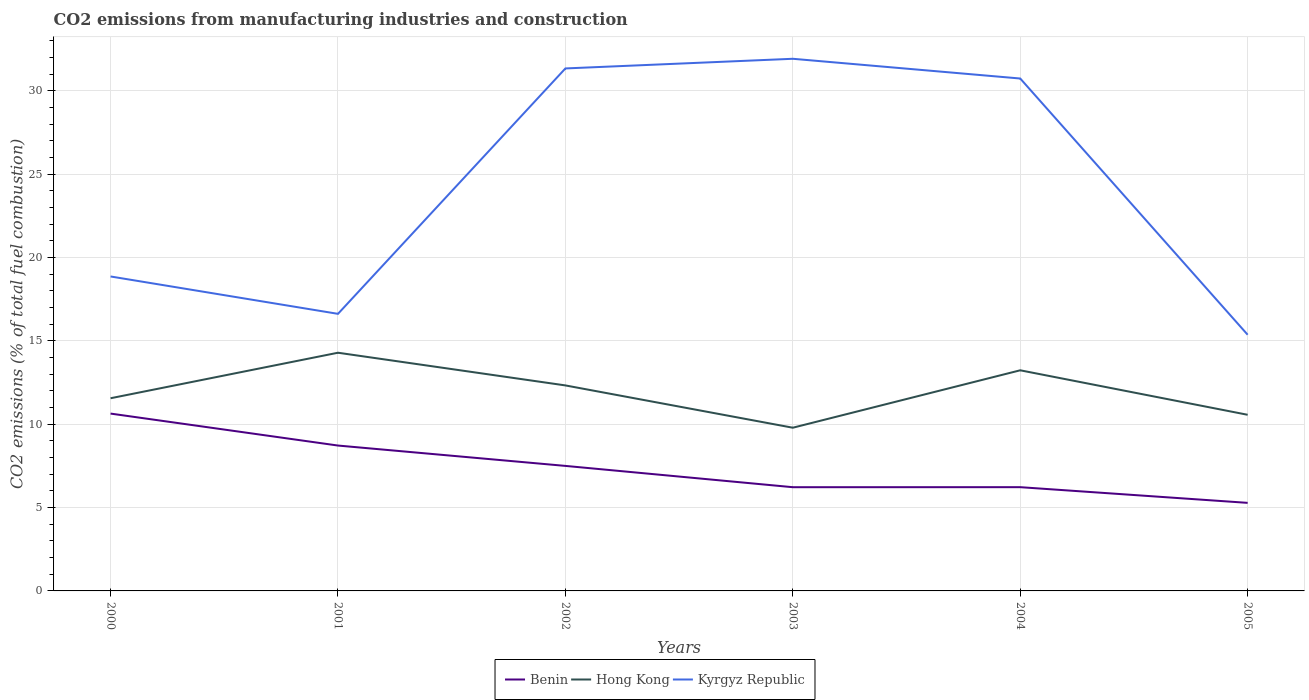How many different coloured lines are there?
Your answer should be very brief. 3. Is the number of lines equal to the number of legend labels?
Your answer should be very brief. Yes. Across all years, what is the maximum amount of CO2 emitted in Benin?
Offer a very short reply. 5.28. What is the total amount of CO2 emitted in Kyrgyz Republic in the graph?
Provide a short and direct response. 1.25. What is the difference between the highest and the second highest amount of CO2 emitted in Kyrgyz Republic?
Offer a very short reply. 16.55. What is the difference between the highest and the lowest amount of CO2 emitted in Kyrgyz Republic?
Your answer should be very brief. 3. Is the amount of CO2 emitted in Benin strictly greater than the amount of CO2 emitted in Kyrgyz Republic over the years?
Offer a terse response. Yes. Does the graph contain any zero values?
Provide a short and direct response. No. How are the legend labels stacked?
Your response must be concise. Horizontal. What is the title of the graph?
Make the answer very short. CO2 emissions from manufacturing industries and construction. What is the label or title of the X-axis?
Your answer should be very brief. Years. What is the label or title of the Y-axis?
Offer a very short reply. CO2 emissions (% of total fuel combustion). What is the CO2 emissions (% of total fuel combustion) in Benin in 2000?
Your response must be concise. 10.64. What is the CO2 emissions (% of total fuel combustion) of Hong Kong in 2000?
Make the answer very short. 11.56. What is the CO2 emissions (% of total fuel combustion) in Kyrgyz Republic in 2000?
Your response must be concise. 18.86. What is the CO2 emissions (% of total fuel combustion) of Benin in 2001?
Ensure brevity in your answer.  8.72. What is the CO2 emissions (% of total fuel combustion) of Hong Kong in 2001?
Your response must be concise. 14.29. What is the CO2 emissions (% of total fuel combustion) of Kyrgyz Republic in 2001?
Give a very brief answer. 16.62. What is the CO2 emissions (% of total fuel combustion) in Benin in 2002?
Your answer should be very brief. 7.5. What is the CO2 emissions (% of total fuel combustion) in Hong Kong in 2002?
Provide a succinct answer. 12.33. What is the CO2 emissions (% of total fuel combustion) of Kyrgyz Republic in 2002?
Your answer should be very brief. 31.34. What is the CO2 emissions (% of total fuel combustion) of Benin in 2003?
Ensure brevity in your answer.  6.22. What is the CO2 emissions (% of total fuel combustion) in Hong Kong in 2003?
Your answer should be very brief. 9.79. What is the CO2 emissions (% of total fuel combustion) of Kyrgyz Republic in 2003?
Provide a short and direct response. 31.92. What is the CO2 emissions (% of total fuel combustion) of Benin in 2004?
Give a very brief answer. 6.22. What is the CO2 emissions (% of total fuel combustion) in Hong Kong in 2004?
Make the answer very short. 13.24. What is the CO2 emissions (% of total fuel combustion) in Kyrgyz Republic in 2004?
Give a very brief answer. 30.74. What is the CO2 emissions (% of total fuel combustion) in Benin in 2005?
Provide a succinct answer. 5.28. What is the CO2 emissions (% of total fuel combustion) in Hong Kong in 2005?
Your answer should be very brief. 10.57. What is the CO2 emissions (% of total fuel combustion) in Kyrgyz Republic in 2005?
Ensure brevity in your answer.  15.37. Across all years, what is the maximum CO2 emissions (% of total fuel combustion) in Benin?
Provide a short and direct response. 10.64. Across all years, what is the maximum CO2 emissions (% of total fuel combustion) in Hong Kong?
Offer a terse response. 14.29. Across all years, what is the maximum CO2 emissions (% of total fuel combustion) of Kyrgyz Republic?
Ensure brevity in your answer.  31.92. Across all years, what is the minimum CO2 emissions (% of total fuel combustion) of Benin?
Provide a short and direct response. 5.28. Across all years, what is the minimum CO2 emissions (% of total fuel combustion) in Hong Kong?
Ensure brevity in your answer.  9.79. Across all years, what is the minimum CO2 emissions (% of total fuel combustion) in Kyrgyz Republic?
Your answer should be compact. 15.37. What is the total CO2 emissions (% of total fuel combustion) of Benin in the graph?
Keep it short and to the point. 44.59. What is the total CO2 emissions (% of total fuel combustion) in Hong Kong in the graph?
Provide a short and direct response. 71.77. What is the total CO2 emissions (% of total fuel combustion) in Kyrgyz Republic in the graph?
Offer a very short reply. 144.86. What is the difference between the CO2 emissions (% of total fuel combustion) in Benin in 2000 and that in 2001?
Your response must be concise. 1.92. What is the difference between the CO2 emissions (% of total fuel combustion) of Hong Kong in 2000 and that in 2001?
Give a very brief answer. -2.73. What is the difference between the CO2 emissions (% of total fuel combustion) in Kyrgyz Republic in 2000 and that in 2001?
Your response must be concise. 2.24. What is the difference between the CO2 emissions (% of total fuel combustion) in Benin in 2000 and that in 2002?
Make the answer very short. 3.14. What is the difference between the CO2 emissions (% of total fuel combustion) in Hong Kong in 2000 and that in 2002?
Keep it short and to the point. -0.77. What is the difference between the CO2 emissions (% of total fuel combustion) of Kyrgyz Republic in 2000 and that in 2002?
Provide a succinct answer. -12.48. What is the difference between the CO2 emissions (% of total fuel combustion) in Benin in 2000 and that in 2003?
Make the answer very short. 4.42. What is the difference between the CO2 emissions (% of total fuel combustion) in Hong Kong in 2000 and that in 2003?
Ensure brevity in your answer.  1.77. What is the difference between the CO2 emissions (% of total fuel combustion) of Kyrgyz Republic in 2000 and that in 2003?
Your response must be concise. -13.06. What is the difference between the CO2 emissions (% of total fuel combustion) in Benin in 2000 and that in 2004?
Offer a very short reply. 4.41. What is the difference between the CO2 emissions (% of total fuel combustion) in Hong Kong in 2000 and that in 2004?
Your response must be concise. -1.68. What is the difference between the CO2 emissions (% of total fuel combustion) in Kyrgyz Republic in 2000 and that in 2004?
Make the answer very short. -11.88. What is the difference between the CO2 emissions (% of total fuel combustion) of Benin in 2000 and that in 2005?
Keep it short and to the point. 5.36. What is the difference between the CO2 emissions (% of total fuel combustion) of Kyrgyz Republic in 2000 and that in 2005?
Offer a terse response. 3.49. What is the difference between the CO2 emissions (% of total fuel combustion) of Benin in 2001 and that in 2002?
Make the answer very short. 1.22. What is the difference between the CO2 emissions (% of total fuel combustion) in Hong Kong in 2001 and that in 2002?
Ensure brevity in your answer.  1.96. What is the difference between the CO2 emissions (% of total fuel combustion) in Kyrgyz Republic in 2001 and that in 2002?
Offer a very short reply. -14.72. What is the difference between the CO2 emissions (% of total fuel combustion) in Benin in 2001 and that in 2003?
Offer a terse response. 2.5. What is the difference between the CO2 emissions (% of total fuel combustion) of Hong Kong in 2001 and that in 2003?
Keep it short and to the point. 4.5. What is the difference between the CO2 emissions (% of total fuel combustion) of Kyrgyz Republic in 2001 and that in 2003?
Your response must be concise. -15.3. What is the difference between the CO2 emissions (% of total fuel combustion) in Benin in 2001 and that in 2004?
Offer a terse response. 2.5. What is the difference between the CO2 emissions (% of total fuel combustion) of Hong Kong in 2001 and that in 2004?
Offer a terse response. 1.05. What is the difference between the CO2 emissions (% of total fuel combustion) of Kyrgyz Republic in 2001 and that in 2004?
Provide a short and direct response. -14.12. What is the difference between the CO2 emissions (% of total fuel combustion) of Benin in 2001 and that in 2005?
Provide a short and direct response. 3.44. What is the difference between the CO2 emissions (% of total fuel combustion) of Hong Kong in 2001 and that in 2005?
Offer a terse response. 3.72. What is the difference between the CO2 emissions (% of total fuel combustion) in Kyrgyz Republic in 2001 and that in 2005?
Your answer should be very brief. 1.25. What is the difference between the CO2 emissions (% of total fuel combustion) of Benin in 2002 and that in 2003?
Offer a terse response. 1.28. What is the difference between the CO2 emissions (% of total fuel combustion) of Hong Kong in 2002 and that in 2003?
Offer a very short reply. 2.54. What is the difference between the CO2 emissions (% of total fuel combustion) of Kyrgyz Republic in 2002 and that in 2003?
Make the answer very short. -0.58. What is the difference between the CO2 emissions (% of total fuel combustion) in Benin in 2002 and that in 2004?
Give a very brief answer. 1.28. What is the difference between the CO2 emissions (% of total fuel combustion) in Hong Kong in 2002 and that in 2004?
Offer a very short reply. -0.91. What is the difference between the CO2 emissions (% of total fuel combustion) in Kyrgyz Republic in 2002 and that in 2004?
Offer a terse response. 0.6. What is the difference between the CO2 emissions (% of total fuel combustion) in Benin in 2002 and that in 2005?
Keep it short and to the point. 2.22. What is the difference between the CO2 emissions (% of total fuel combustion) of Hong Kong in 2002 and that in 2005?
Offer a terse response. 1.76. What is the difference between the CO2 emissions (% of total fuel combustion) of Kyrgyz Republic in 2002 and that in 2005?
Make the answer very short. 15.97. What is the difference between the CO2 emissions (% of total fuel combustion) in Benin in 2003 and that in 2004?
Provide a succinct answer. -0. What is the difference between the CO2 emissions (% of total fuel combustion) in Hong Kong in 2003 and that in 2004?
Your answer should be compact. -3.44. What is the difference between the CO2 emissions (% of total fuel combustion) in Kyrgyz Republic in 2003 and that in 2004?
Provide a succinct answer. 1.18. What is the difference between the CO2 emissions (% of total fuel combustion) of Benin in 2003 and that in 2005?
Offer a terse response. 0.94. What is the difference between the CO2 emissions (% of total fuel combustion) of Hong Kong in 2003 and that in 2005?
Ensure brevity in your answer.  -0.78. What is the difference between the CO2 emissions (% of total fuel combustion) in Kyrgyz Republic in 2003 and that in 2005?
Make the answer very short. 16.55. What is the difference between the CO2 emissions (% of total fuel combustion) in Benin in 2004 and that in 2005?
Your response must be concise. 0.94. What is the difference between the CO2 emissions (% of total fuel combustion) in Hong Kong in 2004 and that in 2005?
Offer a terse response. 2.67. What is the difference between the CO2 emissions (% of total fuel combustion) of Kyrgyz Republic in 2004 and that in 2005?
Offer a terse response. 15.37. What is the difference between the CO2 emissions (% of total fuel combustion) of Benin in 2000 and the CO2 emissions (% of total fuel combustion) of Hong Kong in 2001?
Provide a succinct answer. -3.65. What is the difference between the CO2 emissions (% of total fuel combustion) in Benin in 2000 and the CO2 emissions (% of total fuel combustion) in Kyrgyz Republic in 2001?
Provide a short and direct response. -5.98. What is the difference between the CO2 emissions (% of total fuel combustion) of Hong Kong in 2000 and the CO2 emissions (% of total fuel combustion) of Kyrgyz Republic in 2001?
Give a very brief answer. -5.06. What is the difference between the CO2 emissions (% of total fuel combustion) in Benin in 2000 and the CO2 emissions (% of total fuel combustion) in Hong Kong in 2002?
Keep it short and to the point. -1.69. What is the difference between the CO2 emissions (% of total fuel combustion) in Benin in 2000 and the CO2 emissions (% of total fuel combustion) in Kyrgyz Republic in 2002?
Provide a succinct answer. -20.7. What is the difference between the CO2 emissions (% of total fuel combustion) of Hong Kong in 2000 and the CO2 emissions (% of total fuel combustion) of Kyrgyz Republic in 2002?
Give a very brief answer. -19.78. What is the difference between the CO2 emissions (% of total fuel combustion) in Benin in 2000 and the CO2 emissions (% of total fuel combustion) in Hong Kong in 2003?
Offer a very short reply. 0.85. What is the difference between the CO2 emissions (% of total fuel combustion) of Benin in 2000 and the CO2 emissions (% of total fuel combustion) of Kyrgyz Republic in 2003?
Your answer should be very brief. -21.28. What is the difference between the CO2 emissions (% of total fuel combustion) of Hong Kong in 2000 and the CO2 emissions (% of total fuel combustion) of Kyrgyz Republic in 2003?
Give a very brief answer. -20.36. What is the difference between the CO2 emissions (% of total fuel combustion) of Benin in 2000 and the CO2 emissions (% of total fuel combustion) of Hong Kong in 2004?
Provide a succinct answer. -2.6. What is the difference between the CO2 emissions (% of total fuel combustion) of Benin in 2000 and the CO2 emissions (% of total fuel combustion) of Kyrgyz Republic in 2004?
Give a very brief answer. -20.1. What is the difference between the CO2 emissions (% of total fuel combustion) of Hong Kong in 2000 and the CO2 emissions (% of total fuel combustion) of Kyrgyz Republic in 2004?
Make the answer very short. -19.18. What is the difference between the CO2 emissions (% of total fuel combustion) in Benin in 2000 and the CO2 emissions (% of total fuel combustion) in Hong Kong in 2005?
Make the answer very short. 0.07. What is the difference between the CO2 emissions (% of total fuel combustion) in Benin in 2000 and the CO2 emissions (% of total fuel combustion) in Kyrgyz Republic in 2005?
Offer a very short reply. -4.73. What is the difference between the CO2 emissions (% of total fuel combustion) in Hong Kong in 2000 and the CO2 emissions (% of total fuel combustion) in Kyrgyz Republic in 2005?
Your response must be concise. -3.81. What is the difference between the CO2 emissions (% of total fuel combustion) of Benin in 2001 and the CO2 emissions (% of total fuel combustion) of Hong Kong in 2002?
Make the answer very short. -3.61. What is the difference between the CO2 emissions (% of total fuel combustion) of Benin in 2001 and the CO2 emissions (% of total fuel combustion) of Kyrgyz Republic in 2002?
Your answer should be compact. -22.62. What is the difference between the CO2 emissions (% of total fuel combustion) in Hong Kong in 2001 and the CO2 emissions (% of total fuel combustion) in Kyrgyz Republic in 2002?
Ensure brevity in your answer.  -17.05. What is the difference between the CO2 emissions (% of total fuel combustion) of Benin in 2001 and the CO2 emissions (% of total fuel combustion) of Hong Kong in 2003?
Offer a very short reply. -1.07. What is the difference between the CO2 emissions (% of total fuel combustion) of Benin in 2001 and the CO2 emissions (% of total fuel combustion) of Kyrgyz Republic in 2003?
Your answer should be very brief. -23.2. What is the difference between the CO2 emissions (% of total fuel combustion) in Hong Kong in 2001 and the CO2 emissions (% of total fuel combustion) in Kyrgyz Republic in 2003?
Your answer should be compact. -17.63. What is the difference between the CO2 emissions (% of total fuel combustion) in Benin in 2001 and the CO2 emissions (% of total fuel combustion) in Hong Kong in 2004?
Make the answer very short. -4.51. What is the difference between the CO2 emissions (% of total fuel combustion) of Benin in 2001 and the CO2 emissions (% of total fuel combustion) of Kyrgyz Republic in 2004?
Keep it short and to the point. -22.02. What is the difference between the CO2 emissions (% of total fuel combustion) in Hong Kong in 2001 and the CO2 emissions (% of total fuel combustion) in Kyrgyz Republic in 2004?
Keep it short and to the point. -16.45. What is the difference between the CO2 emissions (% of total fuel combustion) of Benin in 2001 and the CO2 emissions (% of total fuel combustion) of Hong Kong in 2005?
Make the answer very short. -1.84. What is the difference between the CO2 emissions (% of total fuel combustion) of Benin in 2001 and the CO2 emissions (% of total fuel combustion) of Kyrgyz Republic in 2005?
Make the answer very short. -6.65. What is the difference between the CO2 emissions (% of total fuel combustion) in Hong Kong in 2001 and the CO2 emissions (% of total fuel combustion) in Kyrgyz Republic in 2005?
Provide a short and direct response. -1.08. What is the difference between the CO2 emissions (% of total fuel combustion) in Benin in 2002 and the CO2 emissions (% of total fuel combustion) in Hong Kong in 2003?
Offer a terse response. -2.29. What is the difference between the CO2 emissions (% of total fuel combustion) of Benin in 2002 and the CO2 emissions (% of total fuel combustion) of Kyrgyz Republic in 2003?
Provide a short and direct response. -24.42. What is the difference between the CO2 emissions (% of total fuel combustion) in Hong Kong in 2002 and the CO2 emissions (% of total fuel combustion) in Kyrgyz Republic in 2003?
Offer a terse response. -19.59. What is the difference between the CO2 emissions (% of total fuel combustion) of Benin in 2002 and the CO2 emissions (% of total fuel combustion) of Hong Kong in 2004?
Provide a succinct answer. -5.74. What is the difference between the CO2 emissions (% of total fuel combustion) of Benin in 2002 and the CO2 emissions (% of total fuel combustion) of Kyrgyz Republic in 2004?
Make the answer very short. -23.24. What is the difference between the CO2 emissions (% of total fuel combustion) of Hong Kong in 2002 and the CO2 emissions (% of total fuel combustion) of Kyrgyz Republic in 2004?
Offer a very short reply. -18.41. What is the difference between the CO2 emissions (% of total fuel combustion) in Benin in 2002 and the CO2 emissions (% of total fuel combustion) in Hong Kong in 2005?
Provide a short and direct response. -3.07. What is the difference between the CO2 emissions (% of total fuel combustion) in Benin in 2002 and the CO2 emissions (% of total fuel combustion) in Kyrgyz Republic in 2005?
Offer a very short reply. -7.87. What is the difference between the CO2 emissions (% of total fuel combustion) of Hong Kong in 2002 and the CO2 emissions (% of total fuel combustion) of Kyrgyz Republic in 2005?
Keep it short and to the point. -3.04. What is the difference between the CO2 emissions (% of total fuel combustion) of Benin in 2003 and the CO2 emissions (% of total fuel combustion) of Hong Kong in 2004?
Offer a terse response. -7.01. What is the difference between the CO2 emissions (% of total fuel combustion) of Benin in 2003 and the CO2 emissions (% of total fuel combustion) of Kyrgyz Republic in 2004?
Your answer should be very brief. -24.52. What is the difference between the CO2 emissions (% of total fuel combustion) of Hong Kong in 2003 and the CO2 emissions (% of total fuel combustion) of Kyrgyz Republic in 2004?
Your answer should be compact. -20.95. What is the difference between the CO2 emissions (% of total fuel combustion) of Benin in 2003 and the CO2 emissions (% of total fuel combustion) of Hong Kong in 2005?
Offer a very short reply. -4.34. What is the difference between the CO2 emissions (% of total fuel combustion) of Benin in 2003 and the CO2 emissions (% of total fuel combustion) of Kyrgyz Republic in 2005?
Make the answer very short. -9.15. What is the difference between the CO2 emissions (% of total fuel combustion) in Hong Kong in 2003 and the CO2 emissions (% of total fuel combustion) in Kyrgyz Republic in 2005?
Ensure brevity in your answer.  -5.58. What is the difference between the CO2 emissions (% of total fuel combustion) of Benin in 2004 and the CO2 emissions (% of total fuel combustion) of Hong Kong in 2005?
Provide a succinct answer. -4.34. What is the difference between the CO2 emissions (% of total fuel combustion) of Benin in 2004 and the CO2 emissions (% of total fuel combustion) of Kyrgyz Republic in 2005?
Provide a short and direct response. -9.14. What is the difference between the CO2 emissions (% of total fuel combustion) of Hong Kong in 2004 and the CO2 emissions (% of total fuel combustion) of Kyrgyz Republic in 2005?
Your response must be concise. -2.13. What is the average CO2 emissions (% of total fuel combustion) of Benin per year?
Offer a terse response. 7.43. What is the average CO2 emissions (% of total fuel combustion) in Hong Kong per year?
Your response must be concise. 11.96. What is the average CO2 emissions (% of total fuel combustion) of Kyrgyz Republic per year?
Keep it short and to the point. 24.14. In the year 2000, what is the difference between the CO2 emissions (% of total fuel combustion) of Benin and CO2 emissions (% of total fuel combustion) of Hong Kong?
Offer a terse response. -0.92. In the year 2000, what is the difference between the CO2 emissions (% of total fuel combustion) of Benin and CO2 emissions (% of total fuel combustion) of Kyrgyz Republic?
Provide a succinct answer. -8.23. In the year 2000, what is the difference between the CO2 emissions (% of total fuel combustion) in Hong Kong and CO2 emissions (% of total fuel combustion) in Kyrgyz Republic?
Your response must be concise. -7.31. In the year 2001, what is the difference between the CO2 emissions (% of total fuel combustion) in Benin and CO2 emissions (% of total fuel combustion) in Hong Kong?
Provide a succinct answer. -5.57. In the year 2001, what is the difference between the CO2 emissions (% of total fuel combustion) of Benin and CO2 emissions (% of total fuel combustion) of Kyrgyz Republic?
Your answer should be very brief. -7.9. In the year 2001, what is the difference between the CO2 emissions (% of total fuel combustion) in Hong Kong and CO2 emissions (% of total fuel combustion) in Kyrgyz Republic?
Your answer should be compact. -2.33. In the year 2002, what is the difference between the CO2 emissions (% of total fuel combustion) in Benin and CO2 emissions (% of total fuel combustion) in Hong Kong?
Ensure brevity in your answer.  -4.83. In the year 2002, what is the difference between the CO2 emissions (% of total fuel combustion) in Benin and CO2 emissions (% of total fuel combustion) in Kyrgyz Republic?
Keep it short and to the point. -23.84. In the year 2002, what is the difference between the CO2 emissions (% of total fuel combustion) in Hong Kong and CO2 emissions (% of total fuel combustion) in Kyrgyz Republic?
Provide a short and direct response. -19.02. In the year 2003, what is the difference between the CO2 emissions (% of total fuel combustion) of Benin and CO2 emissions (% of total fuel combustion) of Hong Kong?
Your answer should be very brief. -3.57. In the year 2003, what is the difference between the CO2 emissions (% of total fuel combustion) in Benin and CO2 emissions (% of total fuel combustion) in Kyrgyz Republic?
Provide a short and direct response. -25.7. In the year 2003, what is the difference between the CO2 emissions (% of total fuel combustion) in Hong Kong and CO2 emissions (% of total fuel combustion) in Kyrgyz Republic?
Your answer should be very brief. -22.13. In the year 2004, what is the difference between the CO2 emissions (% of total fuel combustion) in Benin and CO2 emissions (% of total fuel combustion) in Hong Kong?
Your response must be concise. -7.01. In the year 2004, what is the difference between the CO2 emissions (% of total fuel combustion) in Benin and CO2 emissions (% of total fuel combustion) in Kyrgyz Republic?
Provide a short and direct response. -24.52. In the year 2004, what is the difference between the CO2 emissions (% of total fuel combustion) in Hong Kong and CO2 emissions (% of total fuel combustion) in Kyrgyz Republic?
Offer a very short reply. -17.5. In the year 2005, what is the difference between the CO2 emissions (% of total fuel combustion) in Benin and CO2 emissions (% of total fuel combustion) in Hong Kong?
Make the answer very short. -5.28. In the year 2005, what is the difference between the CO2 emissions (% of total fuel combustion) in Benin and CO2 emissions (% of total fuel combustion) in Kyrgyz Republic?
Ensure brevity in your answer.  -10.09. In the year 2005, what is the difference between the CO2 emissions (% of total fuel combustion) in Hong Kong and CO2 emissions (% of total fuel combustion) in Kyrgyz Republic?
Offer a very short reply. -4.8. What is the ratio of the CO2 emissions (% of total fuel combustion) of Benin in 2000 to that in 2001?
Keep it short and to the point. 1.22. What is the ratio of the CO2 emissions (% of total fuel combustion) in Hong Kong in 2000 to that in 2001?
Provide a short and direct response. 0.81. What is the ratio of the CO2 emissions (% of total fuel combustion) in Kyrgyz Republic in 2000 to that in 2001?
Keep it short and to the point. 1.13. What is the ratio of the CO2 emissions (% of total fuel combustion) in Benin in 2000 to that in 2002?
Ensure brevity in your answer.  1.42. What is the ratio of the CO2 emissions (% of total fuel combustion) in Hong Kong in 2000 to that in 2002?
Your answer should be very brief. 0.94. What is the ratio of the CO2 emissions (% of total fuel combustion) in Kyrgyz Republic in 2000 to that in 2002?
Ensure brevity in your answer.  0.6. What is the ratio of the CO2 emissions (% of total fuel combustion) in Benin in 2000 to that in 2003?
Keep it short and to the point. 1.71. What is the ratio of the CO2 emissions (% of total fuel combustion) of Hong Kong in 2000 to that in 2003?
Make the answer very short. 1.18. What is the ratio of the CO2 emissions (% of total fuel combustion) of Kyrgyz Republic in 2000 to that in 2003?
Ensure brevity in your answer.  0.59. What is the ratio of the CO2 emissions (% of total fuel combustion) of Benin in 2000 to that in 2004?
Provide a short and direct response. 1.71. What is the ratio of the CO2 emissions (% of total fuel combustion) of Hong Kong in 2000 to that in 2004?
Your answer should be compact. 0.87. What is the ratio of the CO2 emissions (% of total fuel combustion) of Kyrgyz Republic in 2000 to that in 2004?
Offer a terse response. 0.61. What is the ratio of the CO2 emissions (% of total fuel combustion) of Benin in 2000 to that in 2005?
Give a very brief answer. 2.01. What is the ratio of the CO2 emissions (% of total fuel combustion) of Hong Kong in 2000 to that in 2005?
Ensure brevity in your answer.  1.09. What is the ratio of the CO2 emissions (% of total fuel combustion) of Kyrgyz Republic in 2000 to that in 2005?
Ensure brevity in your answer.  1.23. What is the ratio of the CO2 emissions (% of total fuel combustion) of Benin in 2001 to that in 2002?
Keep it short and to the point. 1.16. What is the ratio of the CO2 emissions (% of total fuel combustion) in Hong Kong in 2001 to that in 2002?
Give a very brief answer. 1.16. What is the ratio of the CO2 emissions (% of total fuel combustion) in Kyrgyz Republic in 2001 to that in 2002?
Keep it short and to the point. 0.53. What is the ratio of the CO2 emissions (% of total fuel combustion) of Benin in 2001 to that in 2003?
Your answer should be very brief. 1.4. What is the ratio of the CO2 emissions (% of total fuel combustion) of Hong Kong in 2001 to that in 2003?
Your response must be concise. 1.46. What is the ratio of the CO2 emissions (% of total fuel combustion) in Kyrgyz Republic in 2001 to that in 2003?
Provide a succinct answer. 0.52. What is the ratio of the CO2 emissions (% of total fuel combustion) in Benin in 2001 to that in 2004?
Your answer should be compact. 1.4. What is the ratio of the CO2 emissions (% of total fuel combustion) in Hong Kong in 2001 to that in 2004?
Give a very brief answer. 1.08. What is the ratio of the CO2 emissions (% of total fuel combustion) in Kyrgyz Republic in 2001 to that in 2004?
Keep it short and to the point. 0.54. What is the ratio of the CO2 emissions (% of total fuel combustion) of Benin in 2001 to that in 2005?
Your answer should be very brief. 1.65. What is the ratio of the CO2 emissions (% of total fuel combustion) in Hong Kong in 2001 to that in 2005?
Ensure brevity in your answer.  1.35. What is the ratio of the CO2 emissions (% of total fuel combustion) of Kyrgyz Republic in 2001 to that in 2005?
Your answer should be compact. 1.08. What is the ratio of the CO2 emissions (% of total fuel combustion) of Benin in 2002 to that in 2003?
Your answer should be compact. 1.21. What is the ratio of the CO2 emissions (% of total fuel combustion) of Hong Kong in 2002 to that in 2003?
Your answer should be compact. 1.26. What is the ratio of the CO2 emissions (% of total fuel combustion) in Kyrgyz Republic in 2002 to that in 2003?
Provide a succinct answer. 0.98. What is the ratio of the CO2 emissions (% of total fuel combustion) of Benin in 2002 to that in 2004?
Provide a short and direct response. 1.21. What is the ratio of the CO2 emissions (% of total fuel combustion) of Hong Kong in 2002 to that in 2004?
Provide a short and direct response. 0.93. What is the ratio of the CO2 emissions (% of total fuel combustion) of Kyrgyz Republic in 2002 to that in 2004?
Make the answer very short. 1.02. What is the ratio of the CO2 emissions (% of total fuel combustion) in Benin in 2002 to that in 2005?
Make the answer very short. 1.42. What is the ratio of the CO2 emissions (% of total fuel combustion) of Hong Kong in 2002 to that in 2005?
Keep it short and to the point. 1.17. What is the ratio of the CO2 emissions (% of total fuel combustion) in Kyrgyz Republic in 2002 to that in 2005?
Your answer should be very brief. 2.04. What is the ratio of the CO2 emissions (% of total fuel combustion) in Benin in 2003 to that in 2004?
Your response must be concise. 1. What is the ratio of the CO2 emissions (% of total fuel combustion) of Hong Kong in 2003 to that in 2004?
Your answer should be very brief. 0.74. What is the ratio of the CO2 emissions (% of total fuel combustion) of Kyrgyz Republic in 2003 to that in 2004?
Your answer should be very brief. 1.04. What is the ratio of the CO2 emissions (% of total fuel combustion) of Benin in 2003 to that in 2005?
Your answer should be very brief. 1.18. What is the ratio of the CO2 emissions (% of total fuel combustion) in Hong Kong in 2003 to that in 2005?
Offer a very short reply. 0.93. What is the ratio of the CO2 emissions (% of total fuel combustion) of Kyrgyz Republic in 2003 to that in 2005?
Ensure brevity in your answer.  2.08. What is the ratio of the CO2 emissions (% of total fuel combustion) in Benin in 2004 to that in 2005?
Provide a succinct answer. 1.18. What is the ratio of the CO2 emissions (% of total fuel combustion) of Hong Kong in 2004 to that in 2005?
Your answer should be compact. 1.25. What is the ratio of the CO2 emissions (% of total fuel combustion) of Kyrgyz Republic in 2004 to that in 2005?
Give a very brief answer. 2. What is the difference between the highest and the second highest CO2 emissions (% of total fuel combustion) of Benin?
Make the answer very short. 1.92. What is the difference between the highest and the second highest CO2 emissions (% of total fuel combustion) in Hong Kong?
Offer a terse response. 1.05. What is the difference between the highest and the second highest CO2 emissions (% of total fuel combustion) in Kyrgyz Republic?
Make the answer very short. 0.58. What is the difference between the highest and the lowest CO2 emissions (% of total fuel combustion) in Benin?
Keep it short and to the point. 5.36. What is the difference between the highest and the lowest CO2 emissions (% of total fuel combustion) of Hong Kong?
Provide a short and direct response. 4.5. What is the difference between the highest and the lowest CO2 emissions (% of total fuel combustion) of Kyrgyz Republic?
Your answer should be very brief. 16.55. 